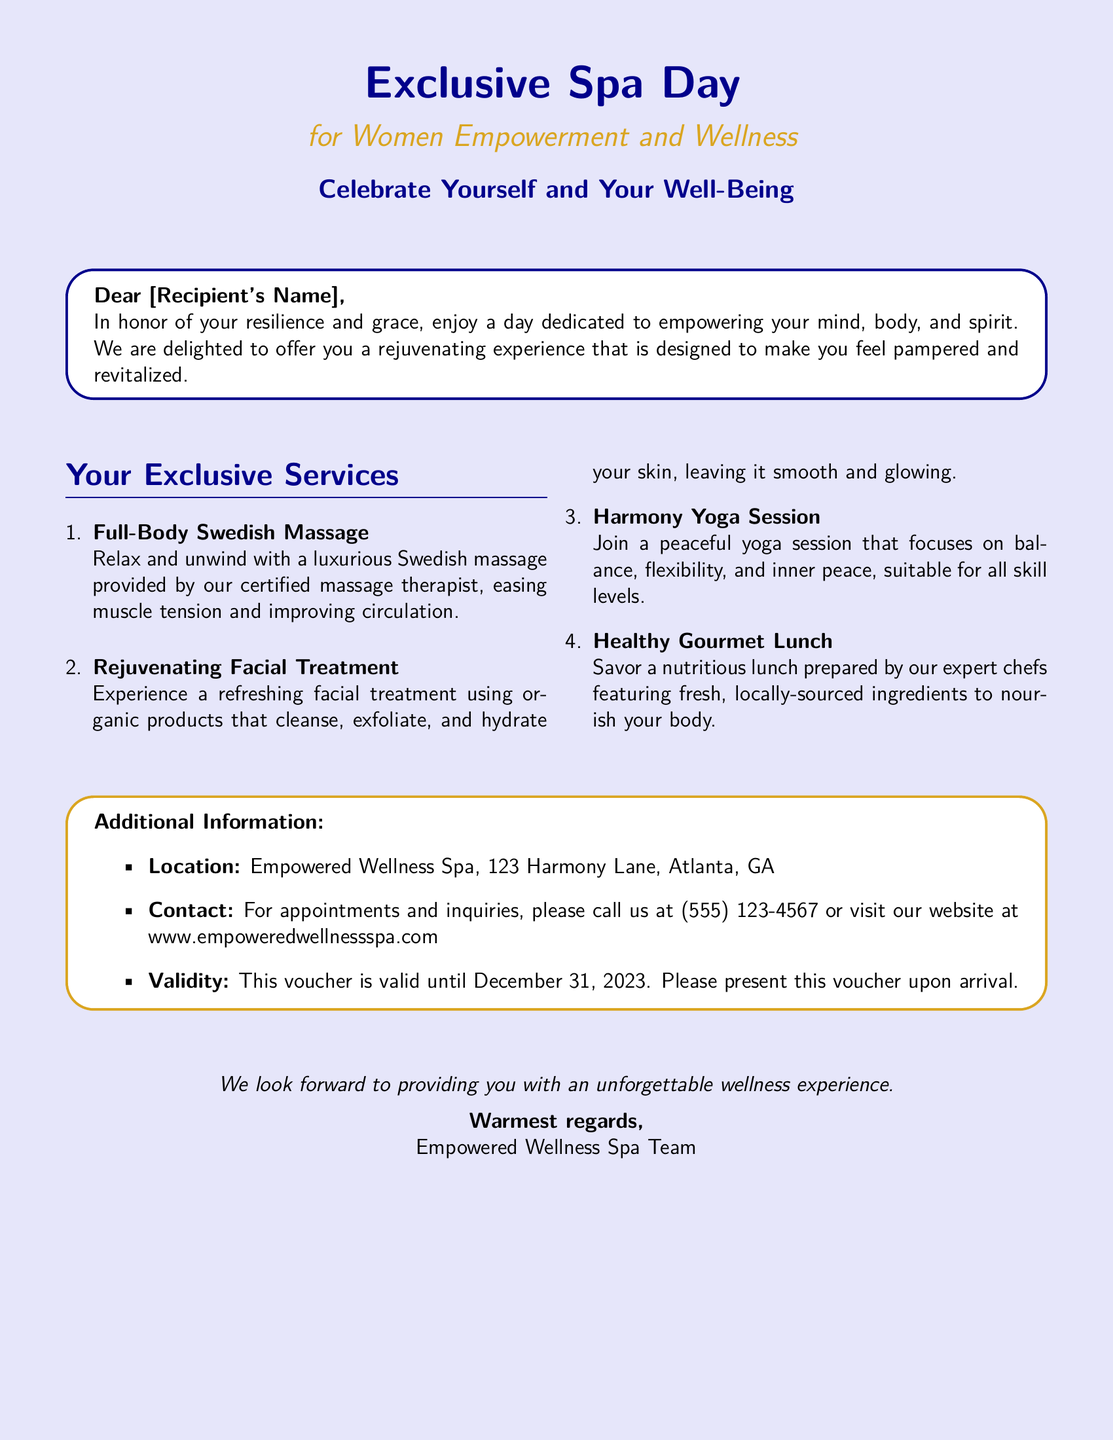What is the name of the spa? The spa's name is mentioned in the document as "Empowered Wellness Spa."
Answer: Empowered Wellness Spa What is included in the spa day experience? The document lists services such as a full-body massage, facial treatment, yoga session, and healthy lunch.
Answer: Full-body massage, facial treatment, yoga session, healthy lunch What is the location of the spa? The address provided in the document is "123 Harmony Lane, Atlanta, GA."
Answer: 123 Harmony Lane, Atlanta, GA When does the voucher expire? The document states the voucher's validity is until December 31, 2023.
Answer: December 31, 2023 What type of lunch is provided? The lunch mentioned in the document is described as "Healthy Gourmet Lunch."
Answer: Healthy Gourmet Lunch Which type of massage is offered? The document specifically mentions "Full-Body Swedish Massage."
Answer: Full-Body Swedish Massage What should you present upon arrival? According to the document, you should present the voucher upon arrival.
Answer: The voucher Is there contact information provided? The document includes a contact number for inquiries: (555) 123-4567.
Answer: (555) 123-4567 What is the theme of the spa day? The document emphasizes the theme as "Women Empowerment and Wellness."
Answer: Women Empowerment and Wellness 